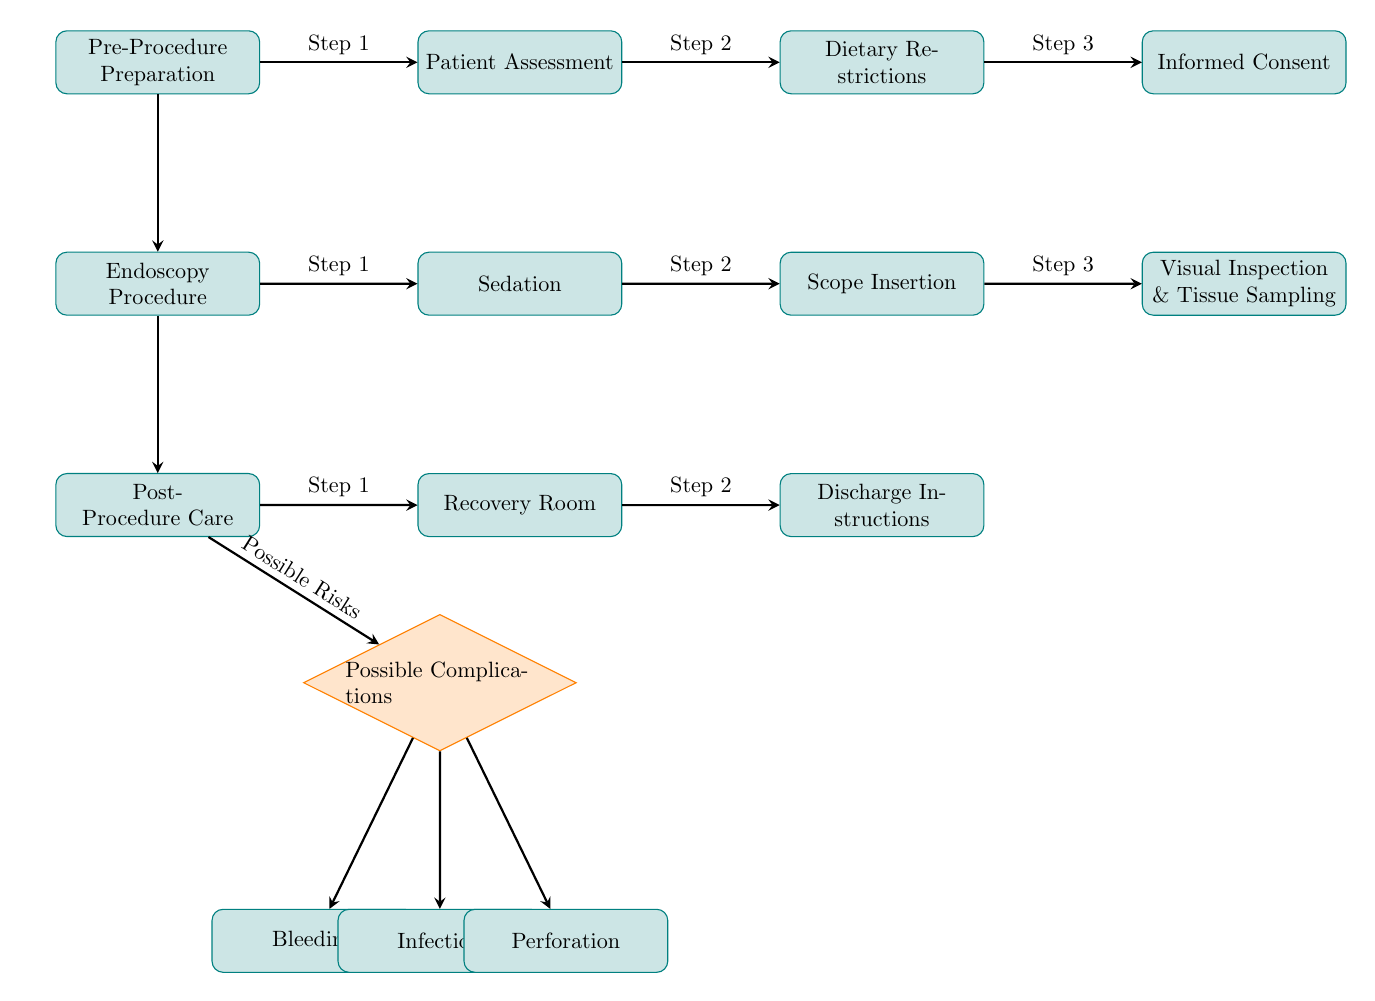What is the first step in the Pre-Procedure Preparation? The first step in the Pre-Procedure Preparation is "Patient Assessment," which can be identified as it is the first node branching out from the "Pre-Procedure Preparation" node.
Answer: Patient Assessment How many steps are included in the Post-Procedure Care phase? In the Post-Procedure Care phase, there are two steps: "Recovery Room" and "Discharge Instructions." By counting the nodes after "Post-Procedure Care," we can see there are two steps.
Answer: 2 What is the relationship between the Endoscopy Procedure and Sedation? The relationship is that Sedation is the first step following the Endoscopy Procedure. This is represented by the directed arrow in the diagram connecting these two nodes.
Answer: Step 1 Name a possible complication post-procedure. The diagram lists three possible complications: "Bleeding," "Infection," and "Perforation." Since the question asks for any one complication, any of these is a correct response.
Answer: Bleeding What step comes immediately after "Visual Inspection & Tissue Sampling"? The step that comes immediately after "Visual Inspection & Tissue Sampling" is "Post-Procedure Care," denoted by the directed arrow descending from the inspection node to the post node.
Answer: Post-Procedure Care How many total nodes are present in the diagram? By counting all nodes in the diagram, we find there are twelve nodes: three in each main phase (Pre-Procedure Preparation, Endoscopy Procedure, Post-Procedure Care) and three complications.
Answer: 12 Which decision node is present in the Post-Procedure Care section? The decision node present in the Post-Procedure Care section is "Possible Complications." This is indicated as a diamond-shaped node descending from "Post-Procedure Care."
Answer: Possible Complications What is the last step before the patient receives discharge instructions? The last step before the patient receives discharge instructions is the "Recovery Room." This can be determined by the flow where "Recovery Room" connects to "Discharge Instructions."
Answer: Recovery Room What is the second step in the Pre-Procedure Preparation? The second step in the Pre-Procedure Preparation is "Dietary Restrictions," identified by its position as the second node following the "Patient Assessment" node.
Answer: Dietary Restrictions 